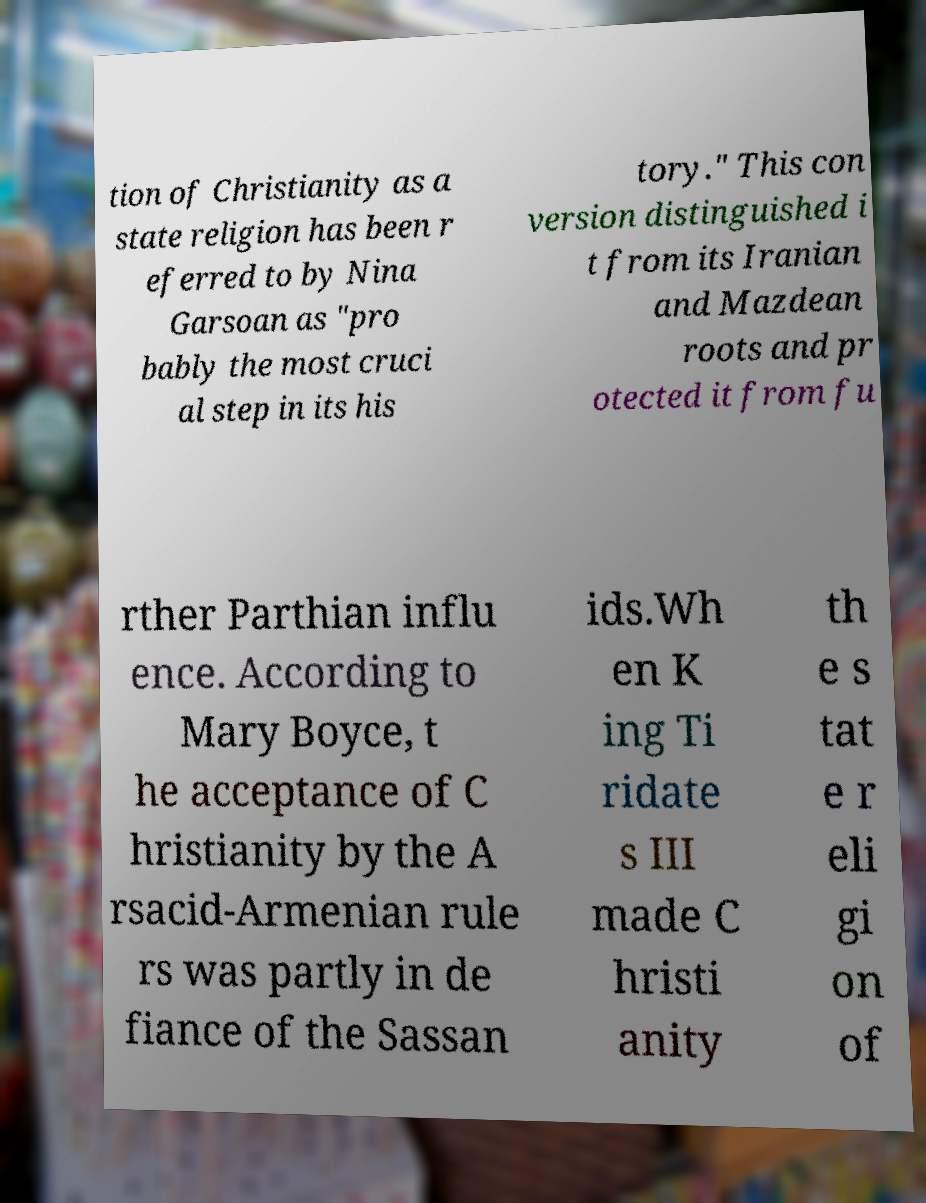Please identify and transcribe the text found in this image. tion of Christianity as a state religion has been r eferred to by Nina Garsoan as "pro bably the most cruci al step in its his tory." This con version distinguished i t from its Iranian and Mazdean roots and pr otected it from fu rther Parthian influ ence. According to Mary Boyce, t he acceptance of C hristianity by the A rsacid-Armenian rule rs was partly in de fiance of the Sassan ids.Wh en K ing Ti ridate s III made C hristi anity th e s tat e r eli gi on of 